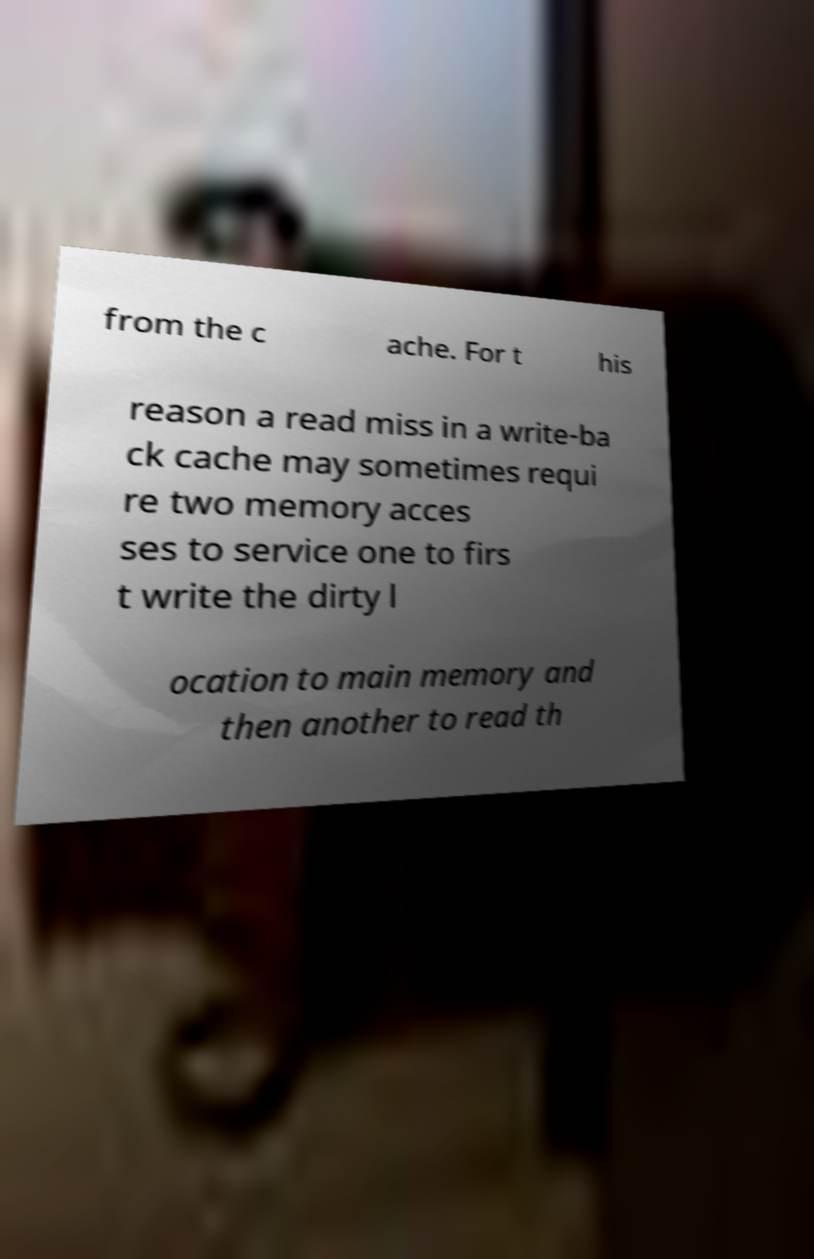Could you assist in decoding the text presented in this image and type it out clearly? from the c ache. For t his reason a read miss in a write-ba ck cache may sometimes requi re two memory acces ses to service one to firs t write the dirty l ocation to main memory and then another to read th 